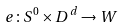<formula> <loc_0><loc_0><loc_500><loc_500>e \colon S ^ { 0 } \times D ^ { d } \to W</formula> 